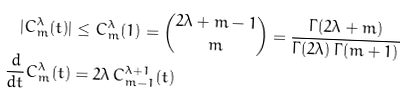Convert formula to latex. <formula><loc_0><loc_0><loc_500><loc_500>| C _ { m } ^ { \lambda } ( t ) | & \leq C _ { m } ^ { \lambda } ( 1 ) = \binom { 2 \lambda + m - 1 } { m } = \frac { \Gamma ( 2 \lambda + m ) } { \Gamma ( 2 \lambda ) \, \Gamma ( m + 1 ) } \\ \frac { d } { d t } C _ { m } ^ { \lambda } ( t ) & = 2 \lambda \, C _ { m - 1 } ^ { \lambda + 1 } ( t )</formula> 